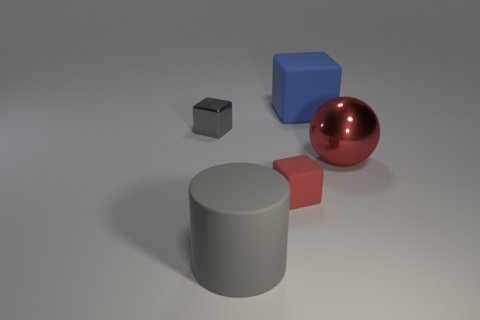How many other things are made of the same material as the cylinder?
Your answer should be very brief. 2. Are there an equal number of large blue rubber cubes to the left of the large rubber cylinder and big cylinders to the left of the red cube?
Your answer should be compact. No. What number of red objects are cylinders or large balls?
Keep it short and to the point. 1. Do the big metal ball and the tiny block that is in front of the large ball have the same color?
Offer a terse response. Yes. What number of other objects are the same color as the shiny cube?
Keep it short and to the point. 1. Is the number of tiny matte things less than the number of rubber objects?
Make the answer very short. Yes. There is a large rubber object in front of the tiny block that is right of the gray matte cylinder; what number of red metal objects are in front of it?
Provide a succinct answer. 0. There is a object that is to the left of the cylinder; what is its size?
Your response must be concise. Small. Do the metal thing that is to the left of the blue thing and the large blue matte object have the same shape?
Your answer should be very brief. Yes. What material is the gray thing that is the same shape as the blue object?
Provide a short and direct response. Metal. 